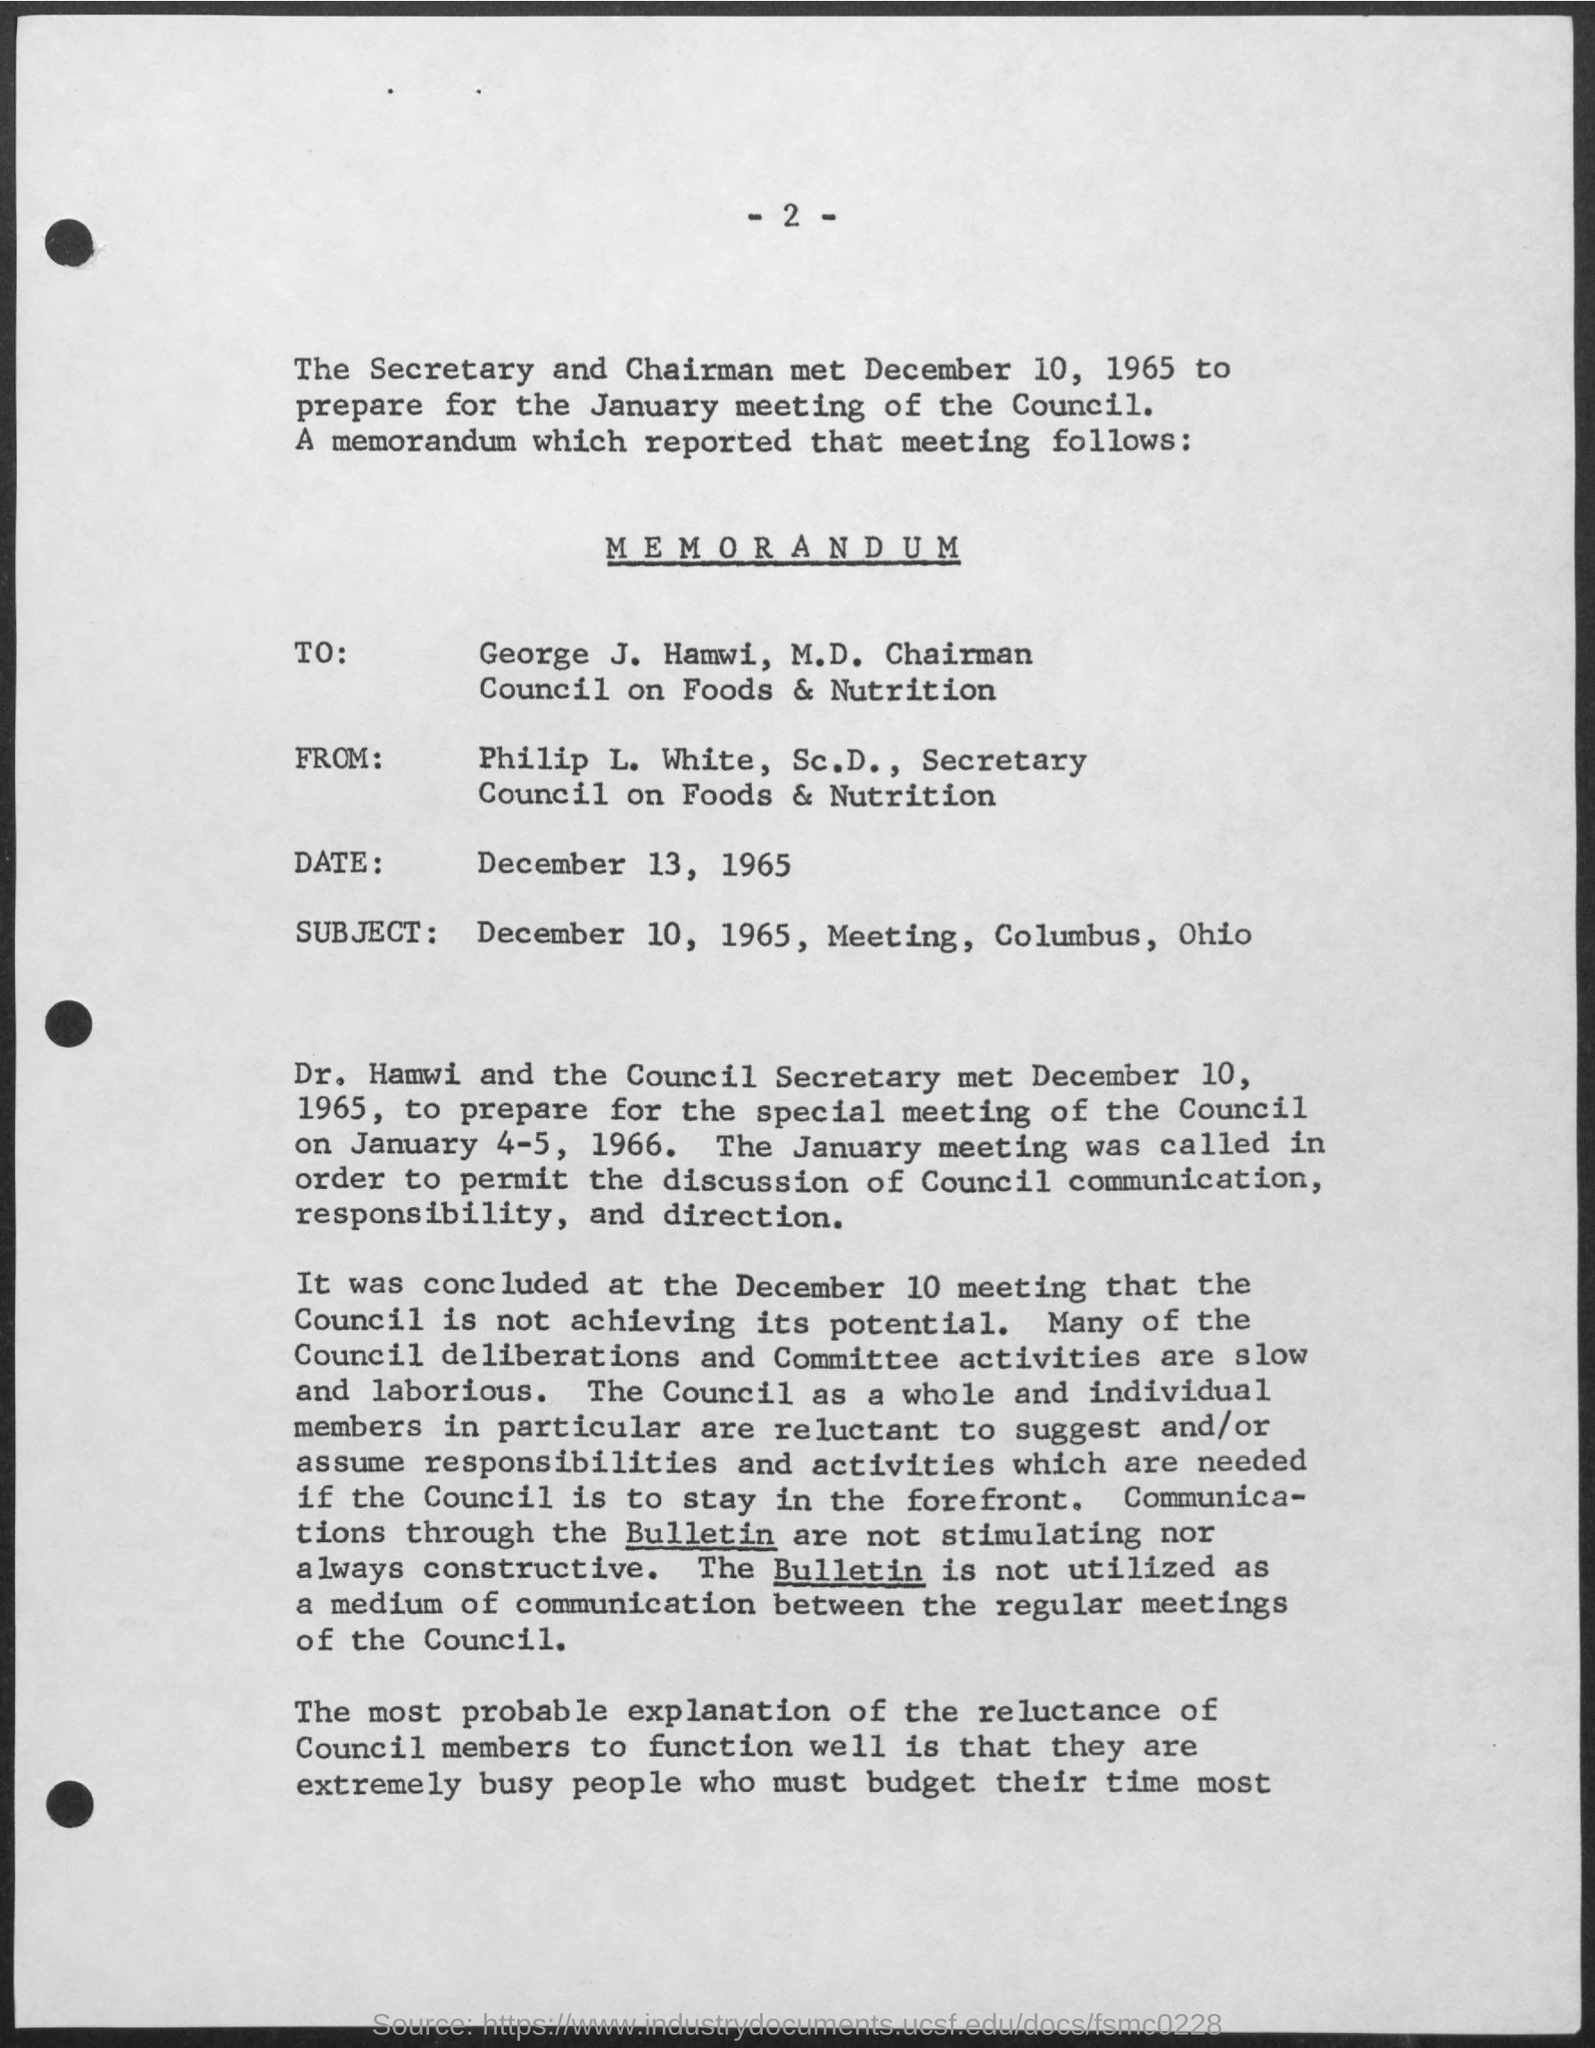To whom the given memorandum was written ?
Your response must be concise. George J. Hamwi. From whom the memorandum was received ?
Make the answer very short. Philip l. white. What is the date mentioned in the given memorandum ?
Offer a very short reply. December 13, 1965. What is the designation of george j. hamwi  as mentioned in the given memorandum ?
Offer a terse response. Chairman. What is the designation of philip l.white as mentioned in the given memorandum ?
Give a very brief answer. Secretary. 